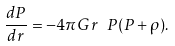Convert formula to latex. <formula><loc_0><loc_0><loc_500><loc_500>\frac { d P } { d r } = - 4 \pi G \, r \ P ( P + \rho ) .</formula> 